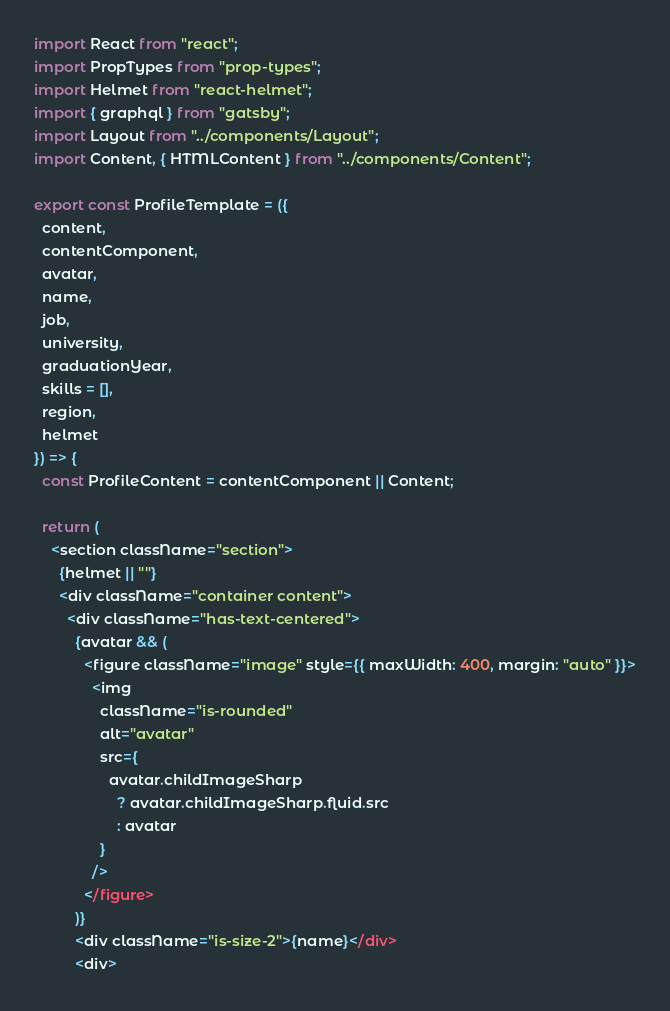Convert code to text. <code><loc_0><loc_0><loc_500><loc_500><_JavaScript_>import React from "react";
import PropTypes from "prop-types";
import Helmet from "react-helmet";
import { graphql } from "gatsby";
import Layout from "../components/Layout";
import Content, { HTMLContent } from "../components/Content";

export const ProfileTemplate = ({
  content,
  contentComponent,
  avatar,
  name,
  job,
  university,
  graduationYear,
  skills = [],
  region,
  helmet
}) => {
  const ProfileContent = contentComponent || Content;

  return (
    <section className="section">
      {helmet || ""}
      <div className="container content">
        <div className="has-text-centered">
          {avatar && (
            <figure className="image" style={{ maxWidth: 400, margin: "auto" }}>
              <img
                className="is-rounded"
                alt="avatar"
                src={
                  avatar.childImageSharp
                    ? avatar.childImageSharp.fluid.src
                    : avatar
                }
              />
            </figure>
          )}
          <div className="is-size-2">{name}</div>
          <div></code> 